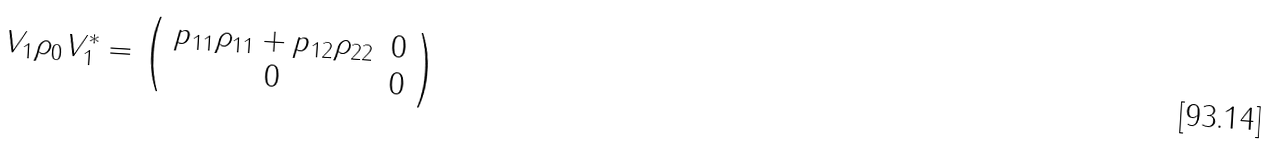<formula> <loc_0><loc_0><loc_500><loc_500>V _ { 1 } \rho _ { 0 } V _ { 1 } ^ { * } = \left ( \begin{array} { c c } p _ { 1 1 } \rho _ { 1 1 } + p _ { 1 2 } \rho _ { 2 2 } & 0 \\ 0 & 0 \end{array} \right )</formula> 